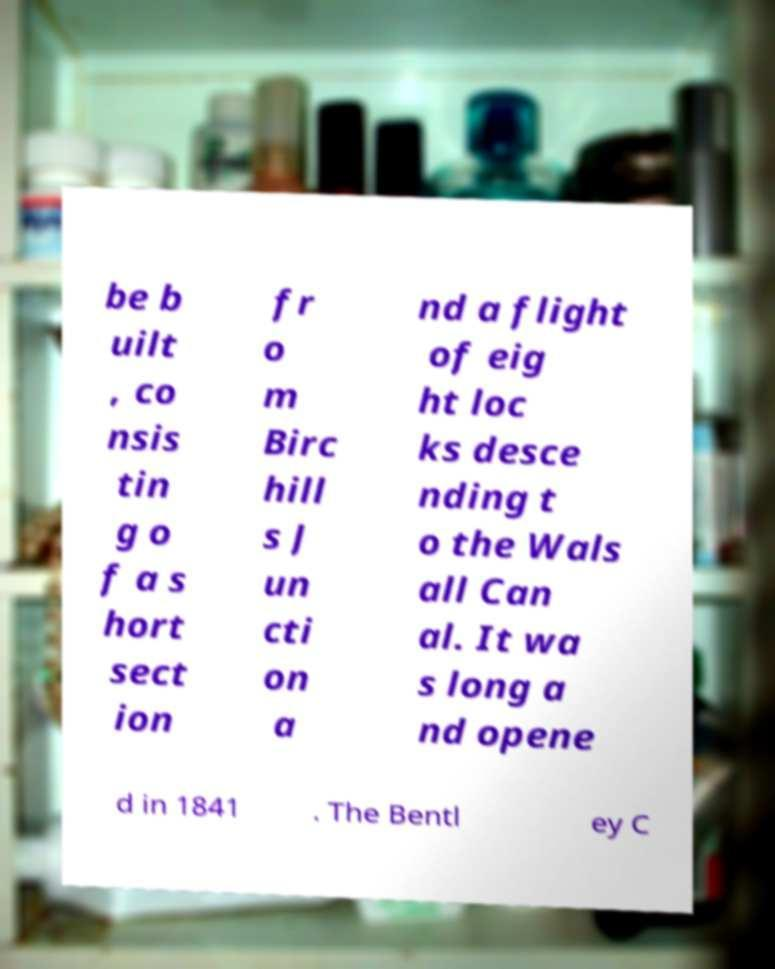Please read and relay the text visible in this image. What does it say? be b uilt , co nsis tin g o f a s hort sect ion fr o m Birc hill s J un cti on a nd a flight of eig ht loc ks desce nding t o the Wals all Can al. It wa s long a nd opene d in 1841 . The Bentl ey C 